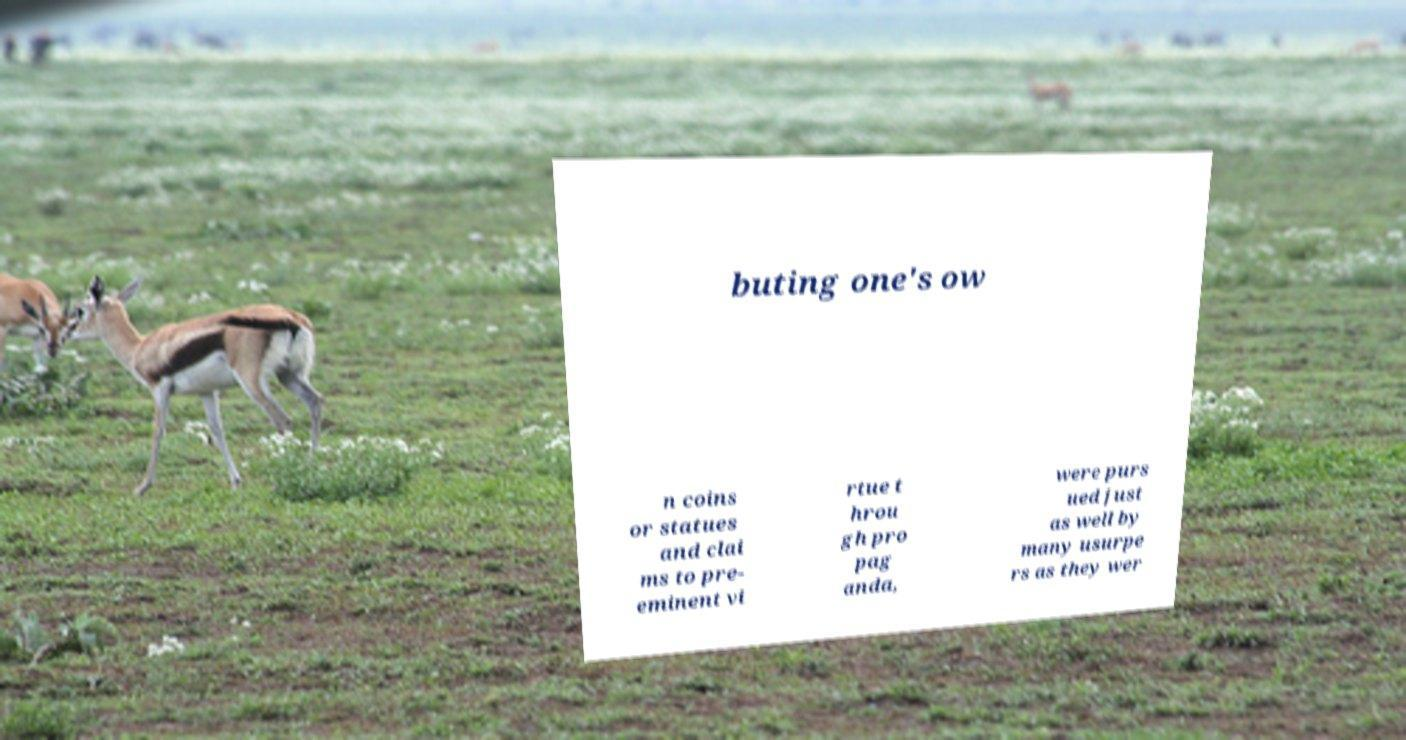Could you extract and type out the text from this image? buting one's ow n coins or statues and clai ms to pre- eminent vi rtue t hrou gh pro pag anda, were purs ued just as well by many usurpe rs as they wer 